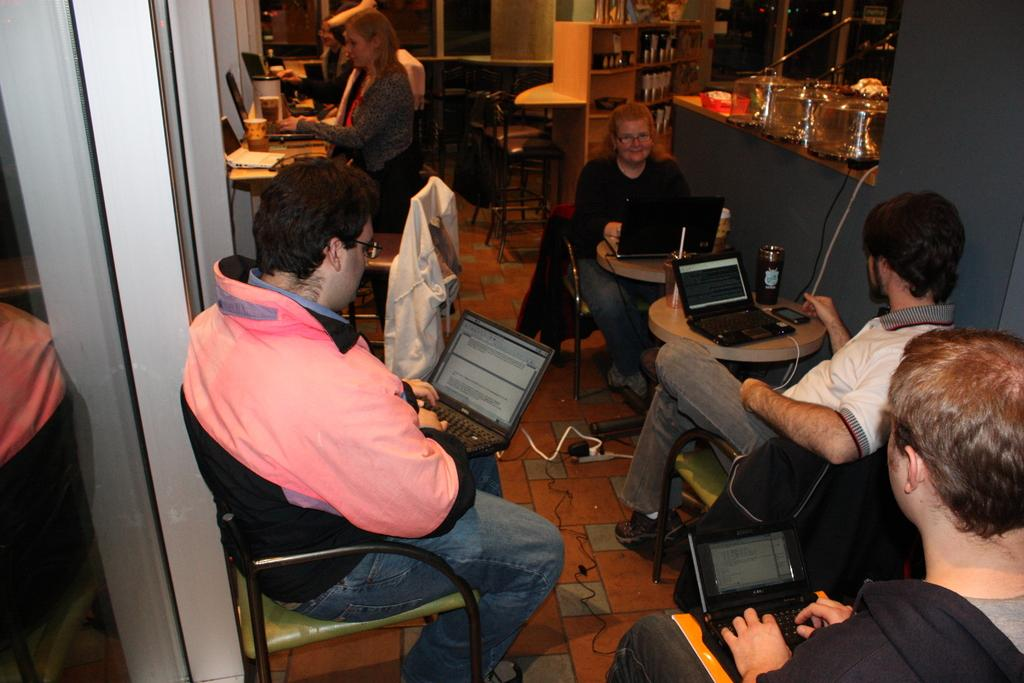Where was the image taken? The image was taken inside a room. What furniture is present in the room? There are tables and chairs in the room. What are the people in the image doing? People are sitting on the chairs. What objects can be seen on the tables? There are glasses and laptops on the tables. What type of straw is being used to decorate the room in the image? There is no straw present in the image; it is not a decorative element. 